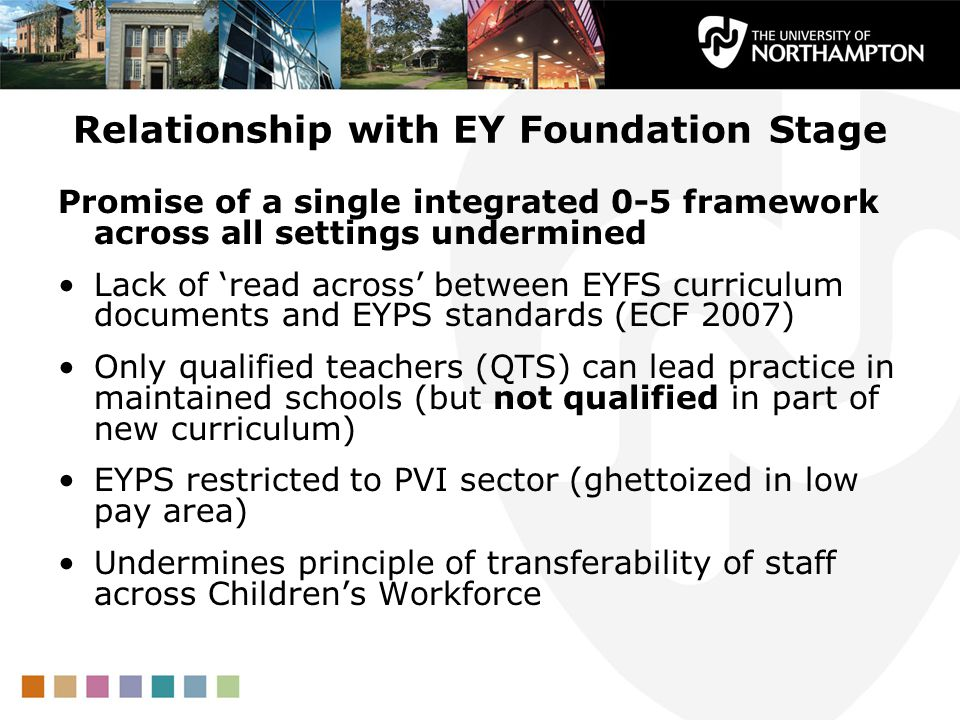Imagine the EYFS framework had no issues. Describe an ideal scenario where the framework operates perfectly. In an ideal scenario where the EYFS framework operates perfectly, there would be seamless integration and alignment between the EYFS curriculum and EYPS standards, facilitating a unified approach to early years education. All educators, regardless of the sector in which they work, would have access to continuous professional development and training, ensuring they are fully qualified and equipped to deliver the curriculum effectively. Staff mobility would be highly fluid, with educators able to move easily between different settings without encountering discrepancies in pay or working conditions. Children would benefit from a consistent, high-quality educational experience, which supports their development and prepares them well for future learning. The framework would be robust, inclusive, and adaptable, meeting the needs of all children and providing a solid foundation for their lifelong learning journey. 